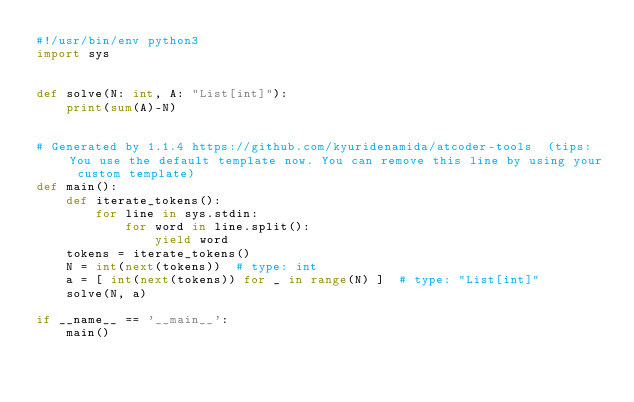Convert code to text. <code><loc_0><loc_0><loc_500><loc_500><_Python_>#!/usr/bin/env python3
import sys


def solve(N: int, A: "List[int]"):
    print(sum(A)-N)


# Generated by 1.1.4 https://github.com/kyuridenamida/atcoder-tools  (tips: You use the default template now. You can remove this line by using your custom template)
def main():
    def iterate_tokens():
        for line in sys.stdin:
            for word in line.split():
                yield word
    tokens = iterate_tokens()
    N = int(next(tokens))  # type: int
    a = [ int(next(tokens)) for _ in range(N) ]  # type: "List[int]"
    solve(N, a)

if __name__ == '__main__':
    main()
</code> 